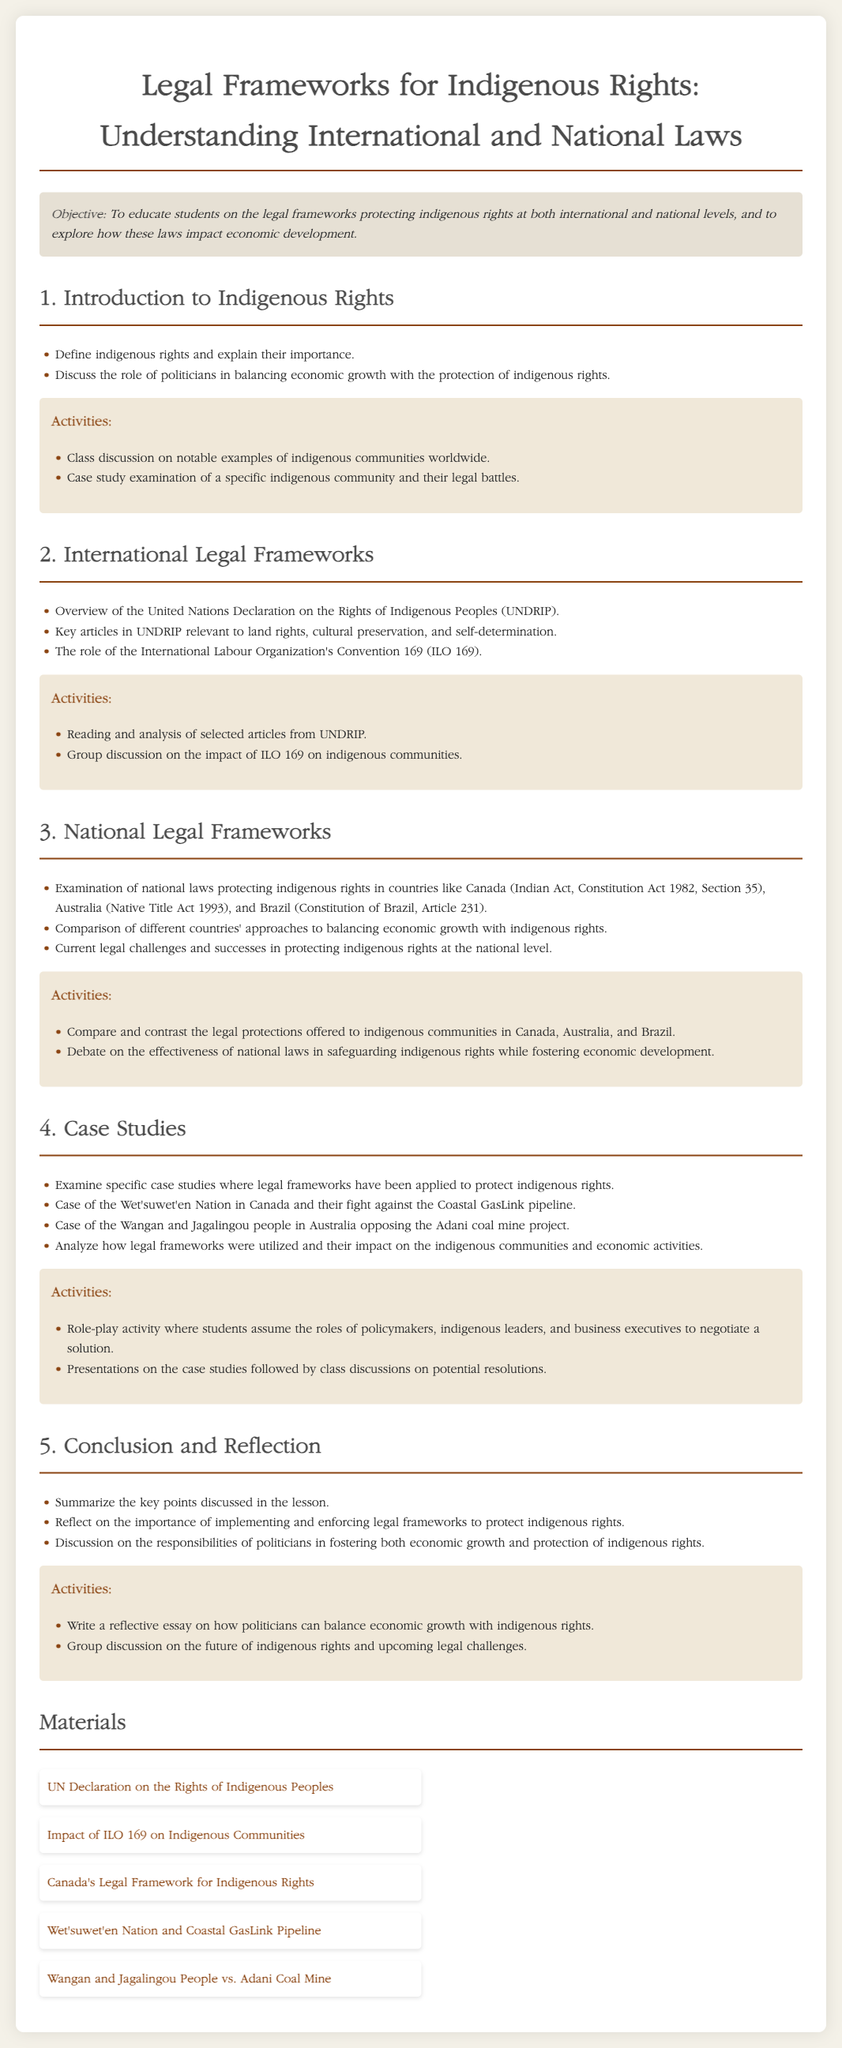what is the main objective of the lesson? The objective of the lesson is stated in the document, focusing on educating students about legal frameworks protecting indigenous rights and their impact on economic development.
Answer: To educate students on the legal frameworks protecting indigenous rights at both international and national levels, and to explore how these laws impact economic development which document outlines the international legal frameworks for indigenous rights? The document mentions that the United Nations Declaration on the Rights of Indigenous Peoples (UNDRIP) is a key international document related to indigenous rights.
Answer: United Nations Declaration on the Rights of Indigenous Peoples (UNDRIP) name one national law that protects indigenous rights in Australia. The lesson plan specifies the Native Title Act 1993 as a national law providing protection for indigenous rights in Australia.
Answer: Native Title Act 1993 what case study is mentioned related to the Wet'suwet'en Nation? The document describes the legal battle involving the Wet'suwet'en Nation and a specific project impacting their rights.
Answer: fight against the Coastal GasLink pipeline which country's constitution includes Article 231 related to indigenous rights? The document states that Brazil's Constitution includes Article 231, which pertains to indigenous rights.
Answer: Constitution of Brazil identify one activity students will participate in regarding national legal frameworks. The lesson plan outlines an activity where students compare and contrast the legal protections for indigenous communities across different countries.
Answer: Compare and contrast the legal protections offered to indigenous communities in Canada, Australia, and Brazil what is a key topic of discussion in the conclusion of the lesson? The conclusion reflects on the responsibilities of politicians regarding their role in safeguarding indigenous rights alongside economic growth.
Answer: responsibilities of politicians in fostering both economic growth and protection of indigenous rights how many key sections are outlined in the lesson plan? Each major topic in the document is categorized into sections, which can be counted for the total.
Answer: 5 